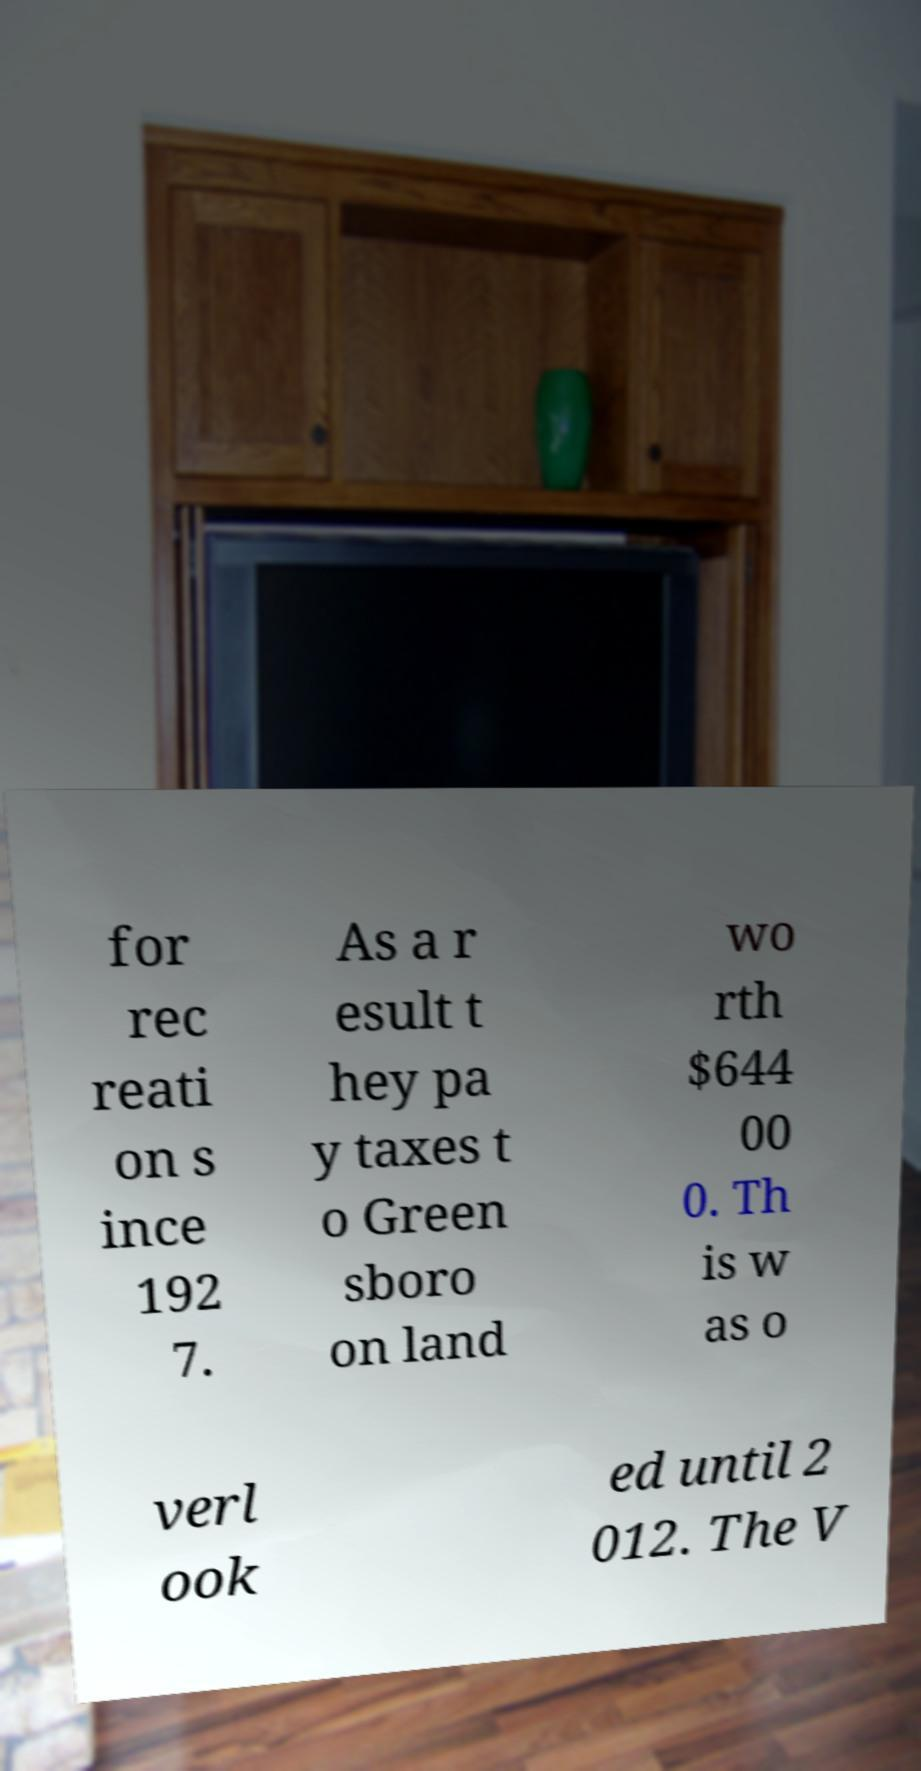Please read and relay the text visible in this image. What does it say? for rec reati on s ince 192 7. As a r esult t hey pa y taxes t o Green sboro on land wo rth $644 00 0. Th is w as o verl ook ed until 2 012. The V 